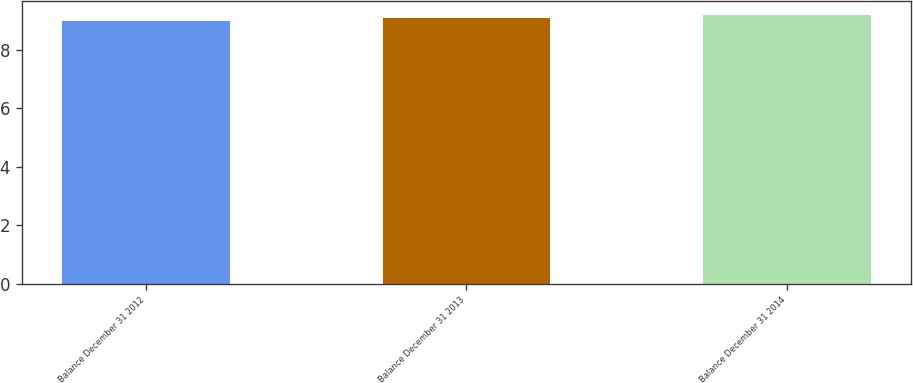<chart> <loc_0><loc_0><loc_500><loc_500><bar_chart><fcel>Balance December 31 2012<fcel>Balance December 31 2013<fcel>Balance December 31 2014<nl><fcel>9<fcel>9.1<fcel>9.2<nl></chart> 